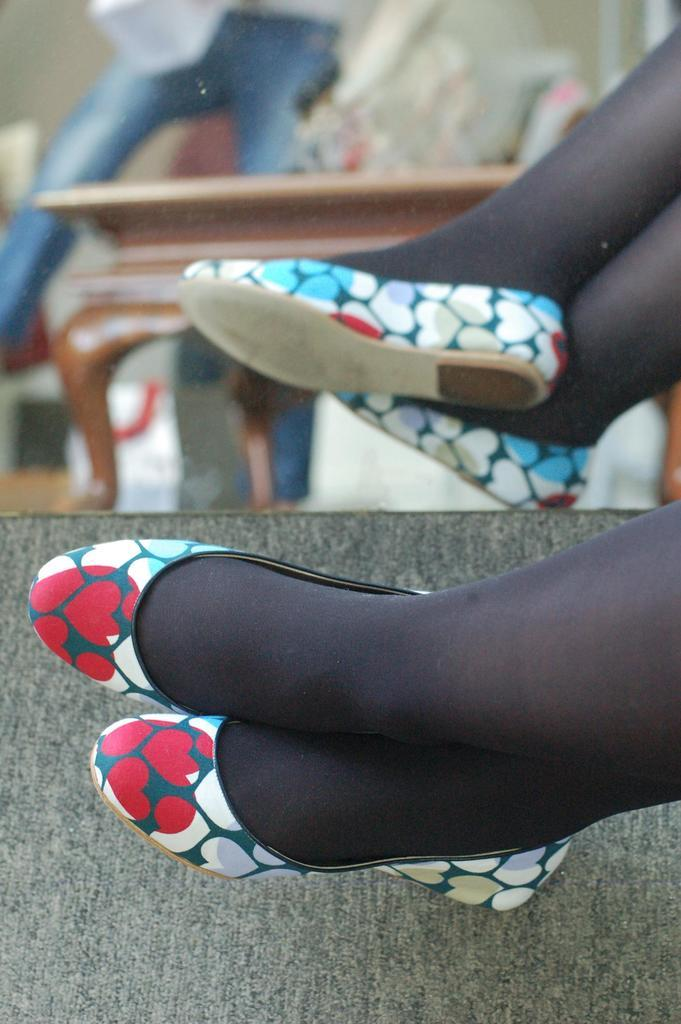What part of a person can be seen in the image? There is a leg of a person in the image. What object is responsible for creating a reflection in the image? There is a reflection in a mirror in the image. What type of soda is being poured into the hole in the image? There is no soda or hole present in the image. What type of jeans is the person wearing in the image? The provided facts do not mention any jeans or clothing worn by the person in the image. 